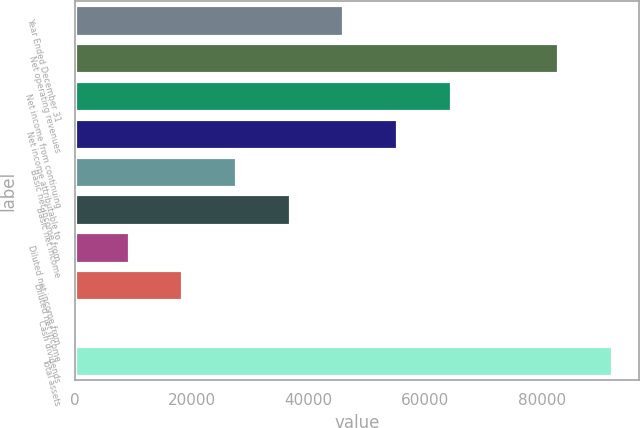Convert chart to OTSL. <chart><loc_0><loc_0><loc_500><loc_500><bar_chart><fcel>Year Ended December 31<fcel>Net operating revenues<fcel>Net income from continuing<fcel>Net income attributable to<fcel>Basic net income from<fcel>Basic net income<fcel>Diluted net income from<fcel>Diluted net income<fcel>Cash dividends<fcel>Total assets<nl><fcel>45984.6<fcel>82771.3<fcel>64378<fcel>55181.3<fcel>27591.3<fcel>36787.9<fcel>9197.9<fcel>18394.6<fcel>1.22<fcel>91968<nl></chart> 